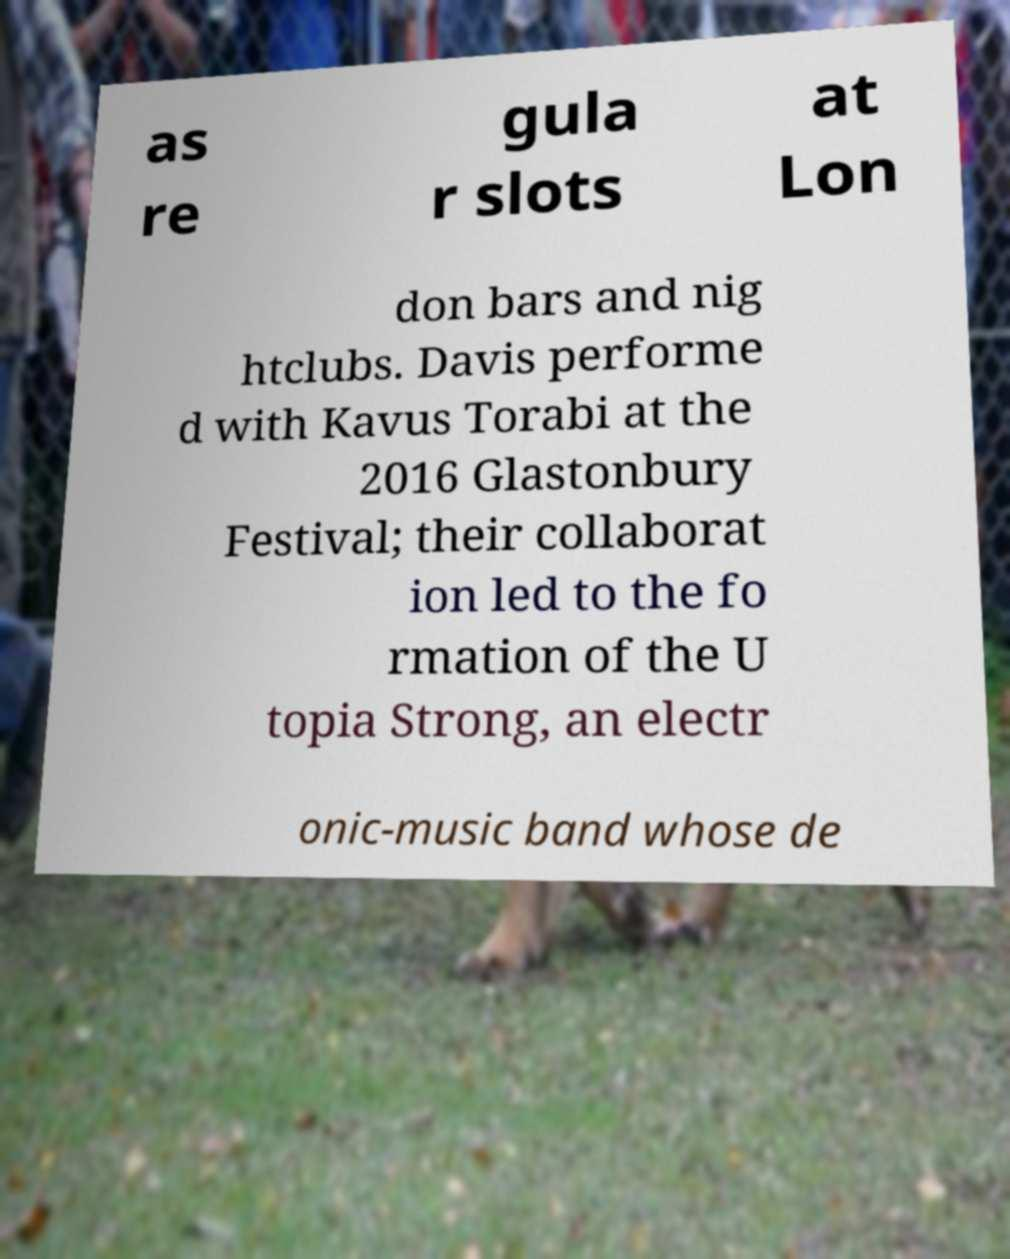What messages or text are displayed in this image? I need them in a readable, typed format. as re gula r slots at Lon don bars and nig htclubs. Davis performe d with Kavus Torabi at the 2016 Glastonbury Festival; their collaborat ion led to the fo rmation of the U topia Strong, an electr onic-music band whose de 